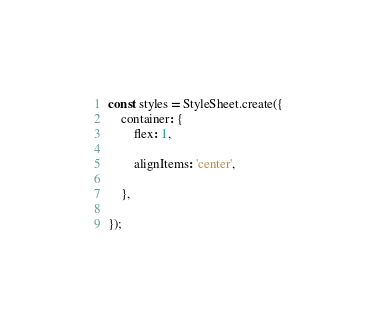Convert code to text. <code><loc_0><loc_0><loc_500><loc_500><_JavaScript_>const styles = StyleSheet.create({
    container: {
        flex: 1,

        alignItems: 'center',

    },

});
</code> 